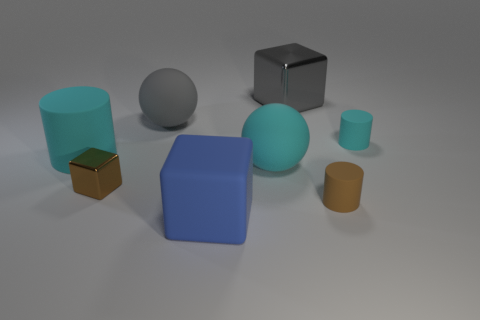Could the setting these objects are in suggest any particular use or context for them? The neutral background and the simplicity of the objects suggest they might be used for a display or a demonstration, possibly for educational purposes, such as teaching about shapes, materials, and colors. 